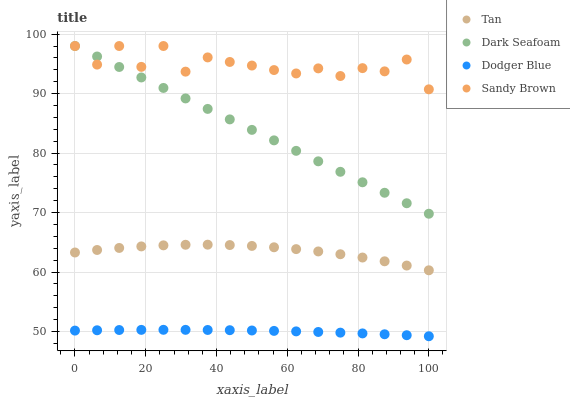Does Dodger Blue have the minimum area under the curve?
Answer yes or no. Yes. Does Sandy Brown have the maximum area under the curve?
Answer yes or no. Yes. Does Tan have the minimum area under the curve?
Answer yes or no. No. Does Tan have the maximum area under the curve?
Answer yes or no. No. Is Dark Seafoam the smoothest?
Answer yes or no. Yes. Is Sandy Brown the roughest?
Answer yes or no. Yes. Is Tan the smoothest?
Answer yes or no. No. Is Tan the roughest?
Answer yes or no. No. Does Dodger Blue have the lowest value?
Answer yes or no. Yes. Does Tan have the lowest value?
Answer yes or no. No. Does Dark Seafoam have the highest value?
Answer yes or no. Yes. Does Tan have the highest value?
Answer yes or no. No. Is Dodger Blue less than Dark Seafoam?
Answer yes or no. Yes. Is Sandy Brown greater than Tan?
Answer yes or no. Yes. Does Dark Seafoam intersect Sandy Brown?
Answer yes or no. Yes. Is Dark Seafoam less than Sandy Brown?
Answer yes or no. No. Is Dark Seafoam greater than Sandy Brown?
Answer yes or no. No. Does Dodger Blue intersect Dark Seafoam?
Answer yes or no. No. 